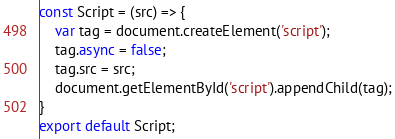<code> <loc_0><loc_0><loc_500><loc_500><_JavaScript_>const Script = (src) => {
    var tag = document.createElement('script');
    tag.async = false;
    tag.src = src;
    document.getElementById('script').appendChild(tag);
}
export default Script;</code> 